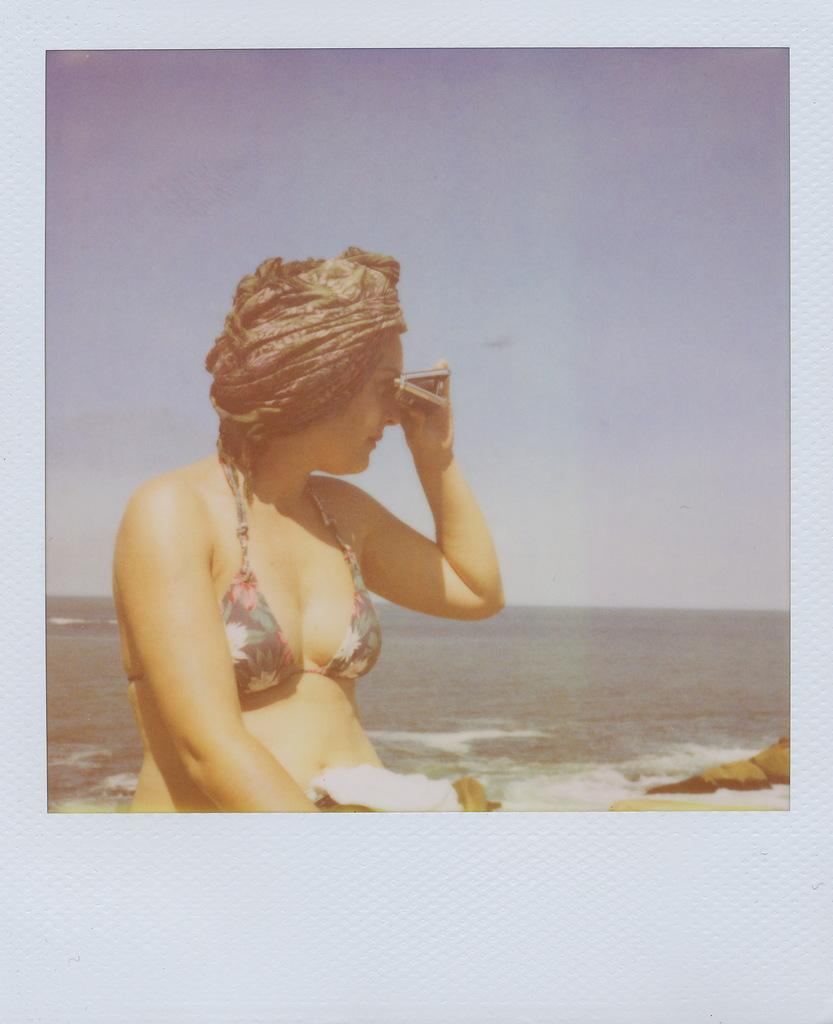What is the woman doing in the image? The woman is sitting in the image. What is the woman holding in the image? The woman is holding an object. What can be seen in the background of the image? There is a sea visible in the background of the image. What is visible at the top of the image? The sky is visible at the top of the image. What type of amusement can be seen in the image? There is no amusement present in the image; it features a woman sitting and holding an object with a sea and sky visible in the background. 